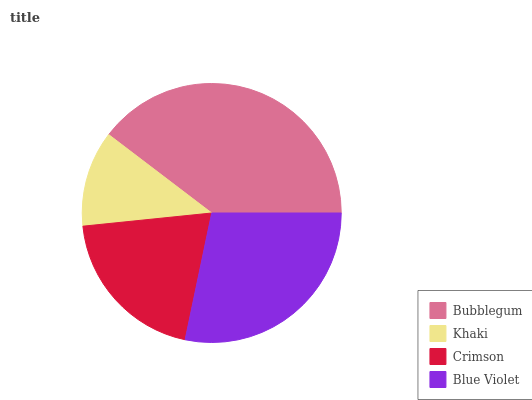Is Khaki the minimum?
Answer yes or no. Yes. Is Bubblegum the maximum?
Answer yes or no. Yes. Is Crimson the minimum?
Answer yes or no. No. Is Crimson the maximum?
Answer yes or no. No. Is Crimson greater than Khaki?
Answer yes or no. Yes. Is Khaki less than Crimson?
Answer yes or no. Yes. Is Khaki greater than Crimson?
Answer yes or no. No. Is Crimson less than Khaki?
Answer yes or no. No. Is Blue Violet the high median?
Answer yes or no. Yes. Is Crimson the low median?
Answer yes or no. Yes. Is Khaki the high median?
Answer yes or no. No. Is Bubblegum the low median?
Answer yes or no. No. 